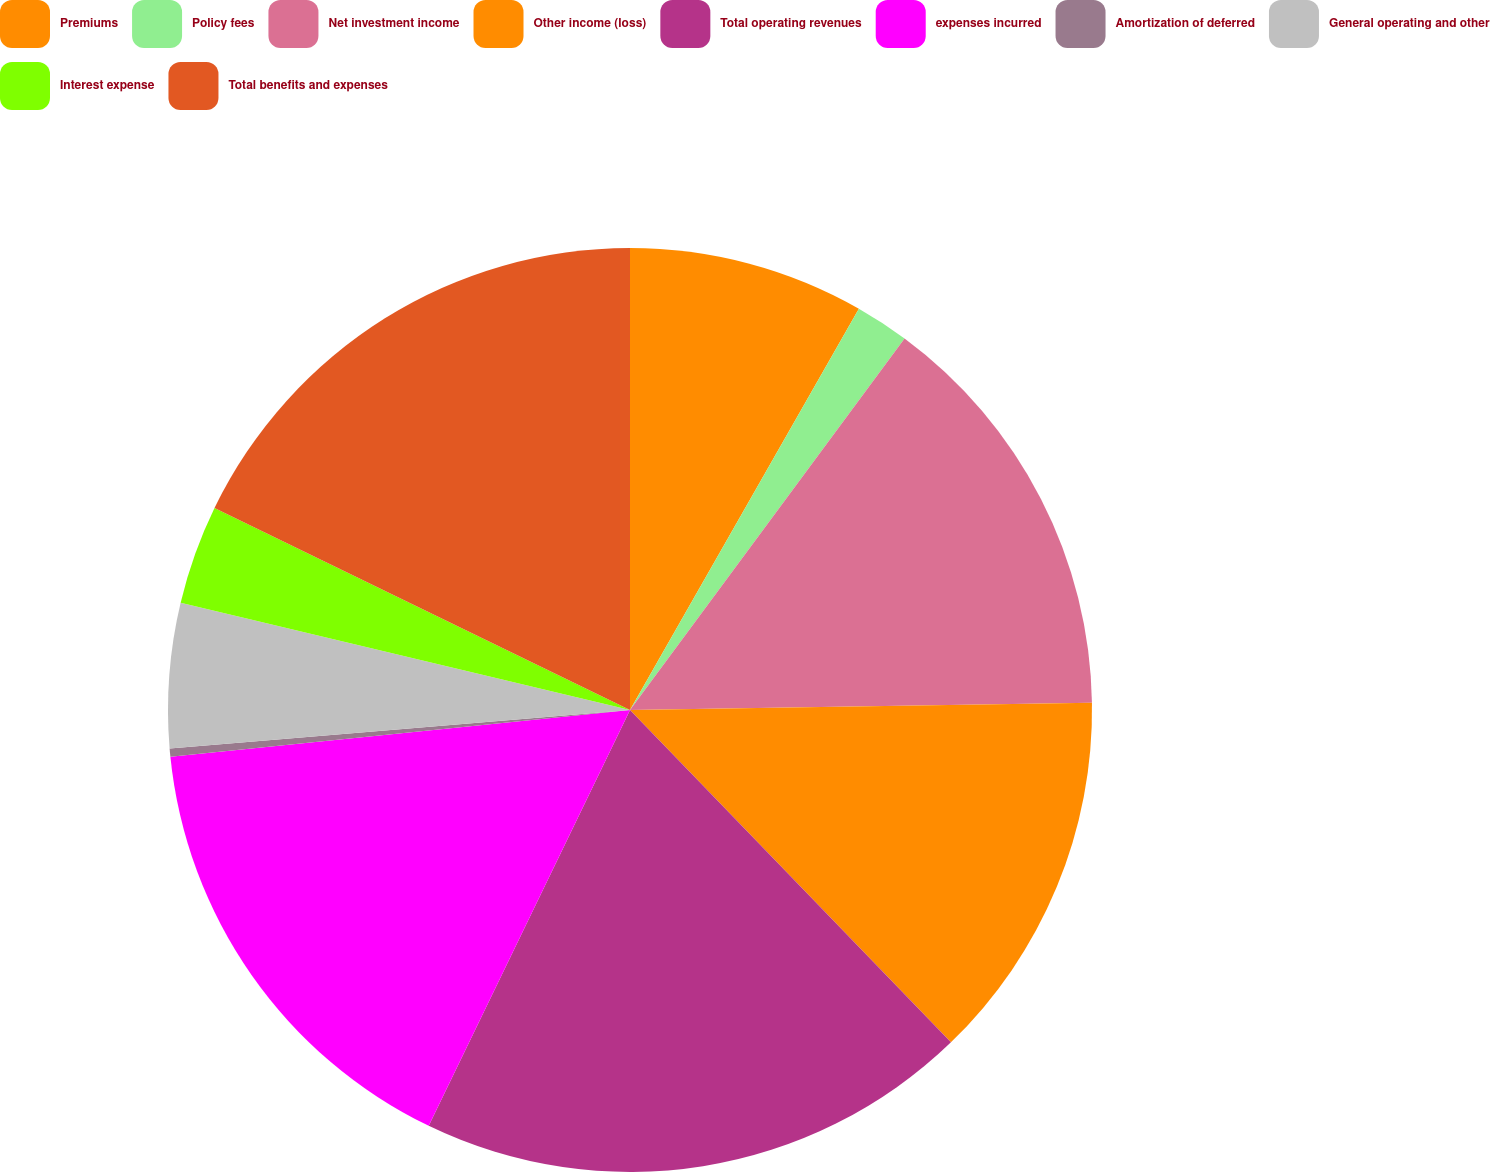<chart> <loc_0><loc_0><loc_500><loc_500><pie_chart><fcel>Premiums<fcel>Policy fees<fcel>Net investment income<fcel>Other income (loss)<fcel>Total operating revenues<fcel>expenses incurred<fcel>Amortization of deferred<fcel>General operating and other<fcel>Interest expense<fcel>Total benefits and expenses<nl><fcel>8.25%<fcel>1.88%<fcel>14.62%<fcel>13.03%<fcel>19.4%<fcel>16.21%<fcel>0.29%<fcel>5.06%<fcel>3.47%<fcel>17.8%<nl></chart> 